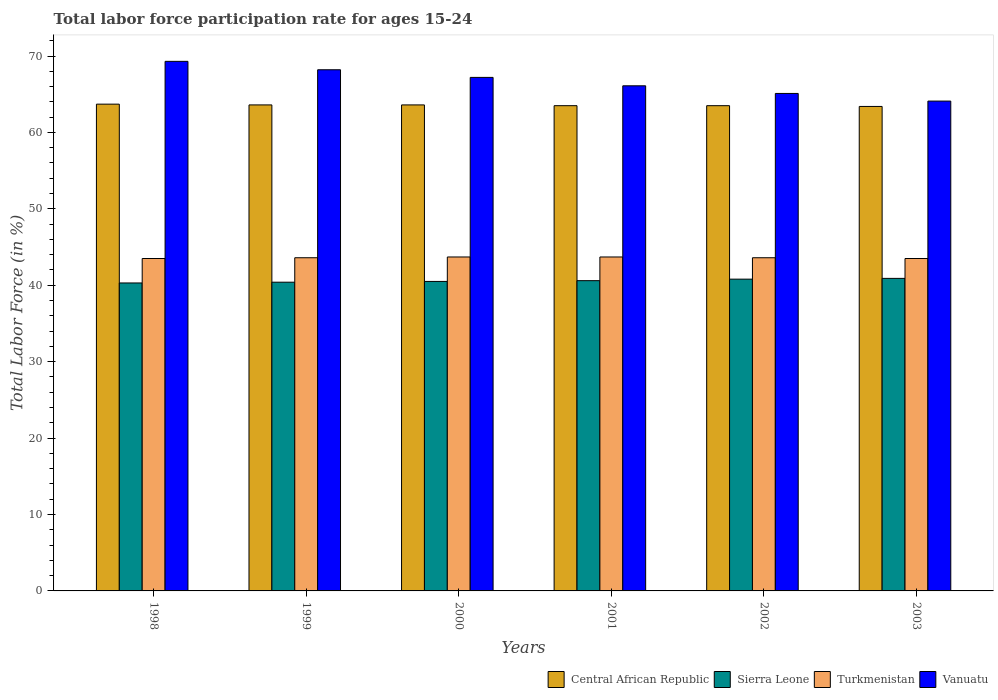How many different coloured bars are there?
Your response must be concise. 4. Are the number of bars per tick equal to the number of legend labels?
Your response must be concise. Yes. Are the number of bars on each tick of the X-axis equal?
Your response must be concise. Yes. How many bars are there on the 6th tick from the left?
Give a very brief answer. 4. What is the labor force participation rate in Turkmenistan in 1999?
Give a very brief answer. 43.6. Across all years, what is the maximum labor force participation rate in Vanuatu?
Offer a terse response. 69.3. Across all years, what is the minimum labor force participation rate in Vanuatu?
Keep it short and to the point. 64.1. In which year was the labor force participation rate in Central African Republic maximum?
Your response must be concise. 1998. In which year was the labor force participation rate in Sierra Leone minimum?
Offer a terse response. 1998. What is the total labor force participation rate in Turkmenistan in the graph?
Your answer should be compact. 261.6. What is the difference between the labor force participation rate in Central African Republic in 2000 and that in 2003?
Your answer should be very brief. 0.2. What is the difference between the labor force participation rate in Vanuatu in 1998 and the labor force participation rate in Turkmenistan in 2002?
Provide a succinct answer. 25.7. What is the average labor force participation rate in Turkmenistan per year?
Your response must be concise. 43.6. In the year 2002, what is the difference between the labor force participation rate in Vanuatu and labor force participation rate in Central African Republic?
Provide a succinct answer. 1.6. What is the ratio of the labor force participation rate in Vanuatu in 2002 to that in 2003?
Offer a very short reply. 1.02. What is the difference between the highest and the second highest labor force participation rate in Central African Republic?
Ensure brevity in your answer.  0.1. What is the difference between the highest and the lowest labor force participation rate in Sierra Leone?
Ensure brevity in your answer.  0.6. In how many years, is the labor force participation rate in Central African Republic greater than the average labor force participation rate in Central African Republic taken over all years?
Give a very brief answer. 3. Is it the case that in every year, the sum of the labor force participation rate in Central African Republic and labor force participation rate in Turkmenistan is greater than the sum of labor force participation rate in Vanuatu and labor force participation rate in Sierra Leone?
Ensure brevity in your answer.  No. What does the 1st bar from the left in 2000 represents?
Offer a terse response. Central African Republic. What does the 1st bar from the right in 2001 represents?
Ensure brevity in your answer.  Vanuatu. How many bars are there?
Offer a very short reply. 24. Are all the bars in the graph horizontal?
Your answer should be compact. No. How many years are there in the graph?
Provide a short and direct response. 6. Are the values on the major ticks of Y-axis written in scientific E-notation?
Provide a short and direct response. No. How many legend labels are there?
Keep it short and to the point. 4. How are the legend labels stacked?
Provide a succinct answer. Horizontal. What is the title of the graph?
Keep it short and to the point. Total labor force participation rate for ages 15-24. What is the Total Labor Force (in %) of Central African Republic in 1998?
Offer a very short reply. 63.7. What is the Total Labor Force (in %) in Sierra Leone in 1998?
Keep it short and to the point. 40.3. What is the Total Labor Force (in %) in Turkmenistan in 1998?
Your answer should be compact. 43.5. What is the Total Labor Force (in %) in Vanuatu in 1998?
Offer a terse response. 69.3. What is the Total Labor Force (in %) in Central African Republic in 1999?
Your response must be concise. 63.6. What is the Total Labor Force (in %) in Sierra Leone in 1999?
Give a very brief answer. 40.4. What is the Total Labor Force (in %) of Turkmenistan in 1999?
Your answer should be compact. 43.6. What is the Total Labor Force (in %) in Vanuatu in 1999?
Offer a very short reply. 68.2. What is the Total Labor Force (in %) in Central African Republic in 2000?
Provide a short and direct response. 63.6. What is the Total Labor Force (in %) in Sierra Leone in 2000?
Offer a very short reply. 40.5. What is the Total Labor Force (in %) in Turkmenistan in 2000?
Your response must be concise. 43.7. What is the Total Labor Force (in %) of Vanuatu in 2000?
Make the answer very short. 67.2. What is the Total Labor Force (in %) of Central African Republic in 2001?
Make the answer very short. 63.5. What is the Total Labor Force (in %) in Sierra Leone in 2001?
Give a very brief answer. 40.6. What is the Total Labor Force (in %) of Turkmenistan in 2001?
Keep it short and to the point. 43.7. What is the Total Labor Force (in %) of Vanuatu in 2001?
Provide a short and direct response. 66.1. What is the Total Labor Force (in %) in Central African Republic in 2002?
Your response must be concise. 63.5. What is the Total Labor Force (in %) in Sierra Leone in 2002?
Keep it short and to the point. 40.8. What is the Total Labor Force (in %) of Turkmenistan in 2002?
Offer a terse response. 43.6. What is the Total Labor Force (in %) in Vanuatu in 2002?
Ensure brevity in your answer.  65.1. What is the Total Labor Force (in %) in Central African Republic in 2003?
Offer a very short reply. 63.4. What is the Total Labor Force (in %) of Sierra Leone in 2003?
Offer a terse response. 40.9. What is the Total Labor Force (in %) in Turkmenistan in 2003?
Provide a succinct answer. 43.5. What is the Total Labor Force (in %) of Vanuatu in 2003?
Your response must be concise. 64.1. Across all years, what is the maximum Total Labor Force (in %) of Central African Republic?
Your response must be concise. 63.7. Across all years, what is the maximum Total Labor Force (in %) in Sierra Leone?
Ensure brevity in your answer.  40.9. Across all years, what is the maximum Total Labor Force (in %) of Turkmenistan?
Your answer should be very brief. 43.7. Across all years, what is the maximum Total Labor Force (in %) in Vanuatu?
Offer a terse response. 69.3. Across all years, what is the minimum Total Labor Force (in %) of Central African Republic?
Offer a terse response. 63.4. Across all years, what is the minimum Total Labor Force (in %) of Sierra Leone?
Provide a succinct answer. 40.3. Across all years, what is the minimum Total Labor Force (in %) of Turkmenistan?
Make the answer very short. 43.5. Across all years, what is the minimum Total Labor Force (in %) of Vanuatu?
Provide a short and direct response. 64.1. What is the total Total Labor Force (in %) of Central African Republic in the graph?
Ensure brevity in your answer.  381.3. What is the total Total Labor Force (in %) of Sierra Leone in the graph?
Offer a very short reply. 243.5. What is the total Total Labor Force (in %) of Turkmenistan in the graph?
Give a very brief answer. 261.6. What is the difference between the Total Labor Force (in %) of Sierra Leone in 1998 and that in 1999?
Keep it short and to the point. -0.1. What is the difference between the Total Labor Force (in %) in Turkmenistan in 1998 and that in 2000?
Your answer should be compact. -0.2. What is the difference between the Total Labor Force (in %) of Central African Republic in 1998 and that in 2001?
Your answer should be compact. 0.2. What is the difference between the Total Labor Force (in %) in Vanuatu in 1998 and that in 2001?
Make the answer very short. 3.2. What is the difference between the Total Labor Force (in %) of Central African Republic in 1998 and that in 2002?
Your answer should be compact. 0.2. What is the difference between the Total Labor Force (in %) of Turkmenistan in 1998 and that in 2002?
Offer a very short reply. -0.1. What is the difference between the Total Labor Force (in %) of Sierra Leone in 1999 and that in 2000?
Offer a very short reply. -0.1. What is the difference between the Total Labor Force (in %) in Turkmenistan in 1999 and that in 2000?
Make the answer very short. -0.1. What is the difference between the Total Labor Force (in %) of Vanuatu in 1999 and that in 2000?
Provide a short and direct response. 1. What is the difference between the Total Labor Force (in %) in Central African Republic in 1999 and that in 2001?
Provide a short and direct response. 0.1. What is the difference between the Total Labor Force (in %) in Turkmenistan in 1999 and that in 2001?
Offer a terse response. -0.1. What is the difference between the Total Labor Force (in %) of Sierra Leone in 1999 and that in 2002?
Offer a very short reply. -0.4. What is the difference between the Total Labor Force (in %) in Central African Republic in 1999 and that in 2003?
Offer a terse response. 0.2. What is the difference between the Total Labor Force (in %) in Sierra Leone in 1999 and that in 2003?
Provide a short and direct response. -0.5. What is the difference between the Total Labor Force (in %) of Turkmenistan in 1999 and that in 2003?
Offer a terse response. 0.1. What is the difference between the Total Labor Force (in %) in Vanuatu in 1999 and that in 2003?
Your answer should be very brief. 4.1. What is the difference between the Total Labor Force (in %) of Central African Republic in 2000 and that in 2001?
Ensure brevity in your answer.  0.1. What is the difference between the Total Labor Force (in %) in Sierra Leone in 2000 and that in 2001?
Offer a terse response. -0.1. What is the difference between the Total Labor Force (in %) of Central African Republic in 2000 and that in 2002?
Make the answer very short. 0.1. What is the difference between the Total Labor Force (in %) of Sierra Leone in 2000 and that in 2002?
Provide a short and direct response. -0.3. What is the difference between the Total Labor Force (in %) in Turkmenistan in 2000 and that in 2002?
Provide a short and direct response. 0.1. What is the difference between the Total Labor Force (in %) of Vanuatu in 2000 and that in 2002?
Offer a terse response. 2.1. What is the difference between the Total Labor Force (in %) of Central African Republic in 2000 and that in 2003?
Give a very brief answer. 0.2. What is the difference between the Total Labor Force (in %) of Sierra Leone in 2000 and that in 2003?
Your answer should be compact. -0.4. What is the difference between the Total Labor Force (in %) of Turkmenistan in 2000 and that in 2003?
Ensure brevity in your answer.  0.2. What is the difference between the Total Labor Force (in %) in Central African Republic in 2001 and that in 2002?
Your response must be concise. 0. What is the difference between the Total Labor Force (in %) in Vanuatu in 2001 and that in 2002?
Provide a succinct answer. 1. What is the difference between the Total Labor Force (in %) of Sierra Leone in 2001 and that in 2003?
Keep it short and to the point. -0.3. What is the difference between the Total Labor Force (in %) of Vanuatu in 2001 and that in 2003?
Provide a succinct answer. 2. What is the difference between the Total Labor Force (in %) of Central African Republic in 2002 and that in 2003?
Your answer should be compact. 0.1. What is the difference between the Total Labor Force (in %) in Vanuatu in 2002 and that in 2003?
Ensure brevity in your answer.  1. What is the difference between the Total Labor Force (in %) in Central African Republic in 1998 and the Total Labor Force (in %) in Sierra Leone in 1999?
Offer a very short reply. 23.3. What is the difference between the Total Labor Force (in %) in Central African Republic in 1998 and the Total Labor Force (in %) in Turkmenistan in 1999?
Make the answer very short. 20.1. What is the difference between the Total Labor Force (in %) in Sierra Leone in 1998 and the Total Labor Force (in %) in Vanuatu in 1999?
Your answer should be very brief. -27.9. What is the difference between the Total Labor Force (in %) in Turkmenistan in 1998 and the Total Labor Force (in %) in Vanuatu in 1999?
Provide a short and direct response. -24.7. What is the difference between the Total Labor Force (in %) in Central African Republic in 1998 and the Total Labor Force (in %) in Sierra Leone in 2000?
Offer a very short reply. 23.2. What is the difference between the Total Labor Force (in %) of Sierra Leone in 1998 and the Total Labor Force (in %) of Turkmenistan in 2000?
Provide a succinct answer. -3.4. What is the difference between the Total Labor Force (in %) of Sierra Leone in 1998 and the Total Labor Force (in %) of Vanuatu in 2000?
Offer a very short reply. -26.9. What is the difference between the Total Labor Force (in %) of Turkmenistan in 1998 and the Total Labor Force (in %) of Vanuatu in 2000?
Make the answer very short. -23.7. What is the difference between the Total Labor Force (in %) of Central African Republic in 1998 and the Total Labor Force (in %) of Sierra Leone in 2001?
Ensure brevity in your answer.  23.1. What is the difference between the Total Labor Force (in %) in Central African Republic in 1998 and the Total Labor Force (in %) in Turkmenistan in 2001?
Keep it short and to the point. 20. What is the difference between the Total Labor Force (in %) of Sierra Leone in 1998 and the Total Labor Force (in %) of Vanuatu in 2001?
Your answer should be compact. -25.8. What is the difference between the Total Labor Force (in %) in Turkmenistan in 1998 and the Total Labor Force (in %) in Vanuatu in 2001?
Provide a short and direct response. -22.6. What is the difference between the Total Labor Force (in %) in Central African Republic in 1998 and the Total Labor Force (in %) in Sierra Leone in 2002?
Provide a short and direct response. 22.9. What is the difference between the Total Labor Force (in %) of Central African Republic in 1998 and the Total Labor Force (in %) of Turkmenistan in 2002?
Ensure brevity in your answer.  20.1. What is the difference between the Total Labor Force (in %) of Sierra Leone in 1998 and the Total Labor Force (in %) of Vanuatu in 2002?
Provide a succinct answer. -24.8. What is the difference between the Total Labor Force (in %) in Turkmenistan in 1998 and the Total Labor Force (in %) in Vanuatu in 2002?
Provide a succinct answer. -21.6. What is the difference between the Total Labor Force (in %) in Central African Republic in 1998 and the Total Labor Force (in %) in Sierra Leone in 2003?
Make the answer very short. 22.8. What is the difference between the Total Labor Force (in %) of Central African Republic in 1998 and the Total Labor Force (in %) of Turkmenistan in 2003?
Offer a terse response. 20.2. What is the difference between the Total Labor Force (in %) of Central African Republic in 1998 and the Total Labor Force (in %) of Vanuatu in 2003?
Ensure brevity in your answer.  -0.4. What is the difference between the Total Labor Force (in %) in Sierra Leone in 1998 and the Total Labor Force (in %) in Vanuatu in 2003?
Make the answer very short. -23.8. What is the difference between the Total Labor Force (in %) of Turkmenistan in 1998 and the Total Labor Force (in %) of Vanuatu in 2003?
Your response must be concise. -20.6. What is the difference between the Total Labor Force (in %) of Central African Republic in 1999 and the Total Labor Force (in %) of Sierra Leone in 2000?
Provide a short and direct response. 23.1. What is the difference between the Total Labor Force (in %) in Sierra Leone in 1999 and the Total Labor Force (in %) in Turkmenistan in 2000?
Make the answer very short. -3.3. What is the difference between the Total Labor Force (in %) in Sierra Leone in 1999 and the Total Labor Force (in %) in Vanuatu in 2000?
Provide a short and direct response. -26.8. What is the difference between the Total Labor Force (in %) in Turkmenistan in 1999 and the Total Labor Force (in %) in Vanuatu in 2000?
Your response must be concise. -23.6. What is the difference between the Total Labor Force (in %) of Central African Republic in 1999 and the Total Labor Force (in %) of Sierra Leone in 2001?
Offer a very short reply. 23. What is the difference between the Total Labor Force (in %) in Central African Republic in 1999 and the Total Labor Force (in %) in Vanuatu in 2001?
Offer a terse response. -2.5. What is the difference between the Total Labor Force (in %) in Sierra Leone in 1999 and the Total Labor Force (in %) in Vanuatu in 2001?
Offer a terse response. -25.7. What is the difference between the Total Labor Force (in %) in Turkmenistan in 1999 and the Total Labor Force (in %) in Vanuatu in 2001?
Provide a short and direct response. -22.5. What is the difference between the Total Labor Force (in %) in Central African Republic in 1999 and the Total Labor Force (in %) in Sierra Leone in 2002?
Ensure brevity in your answer.  22.8. What is the difference between the Total Labor Force (in %) of Sierra Leone in 1999 and the Total Labor Force (in %) of Vanuatu in 2002?
Give a very brief answer. -24.7. What is the difference between the Total Labor Force (in %) of Turkmenistan in 1999 and the Total Labor Force (in %) of Vanuatu in 2002?
Make the answer very short. -21.5. What is the difference between the Total Labor Force (in %) of Central African Republic in 1999 and the Total Labor Force (in %) of Sierra Leone in 2003?
Give a very brief answer. 22.7. What is the difference between the Total Labor Force (in %) of Central African Republic in 1999 and the Total Labor Force (in %) of Turkmenistan in 2003?
Make the answer very short. 20.1. What is the difference between the Total Labor Force (in %) of Central African Republic in 1999 and the Total Labor Force (in %) of Vanuatu in 2003?
Give a very brief answer. -0.5. What is the difference between the Total Labor Force (in %) of Sierra Leone in 1999 and the Total Labor Force (in %) of Vanuatu in 2003?
Your answer should be very brief. -23.7. What is the difference between the Total Labor Force (in %) of Turkmenistan in 1999 and the Total Labor Force (in %) of Vanuatu in 2003?
Offer a terse response. -20.5. What is the difference between the Total Labor Force (in %) in Sierra Leone in 2000 and the Total Labor Force (in %) in Vanuatu in 2001?
Offer a terse response. -25.6. What is the difference between the Total Labor Force (in %) of Turkmenistan in 2000 and the Total Labor Force (in %) of Vanuatu in 2001?
Your answer should be compact. -22.4. What is the difference between the Total Labor Force (in %) in Central African Republic in 2000 and the Total Labor Force (in %) in Sierra Leone in 2002?
Provide a short and direct response. 22.8. What is the difference between the Total Labor Force (in %) of Central African Republic in 2000 and the Total Labor Force (in %) of Turkmenistan in 2002?
Your response must be concise. 20. What is the difference between the Total Labor Force (in %) of Central African Republic in 2000 and the Total Labor Force (in %) of Vanuatu in 2002?
Your answer should be compact. -1.5. What is the difference between the Total Labor Force (in %) in Sierra Leone in 2000 and the Total Labor Force (in %) in Turkmenistan in 2002?
Keep it short and to the point. -3.1. What is the difference between the Total Labor Force (in %) in Sierra Leone in 2000 and the Total Labor Force (in %) in Vanuatu in 2002?
Keep it short and to the point. -24.6. What is the difference between the Total Labor Force (in %) in Turkmenistan in 2000 and the Total Labor Force (in %) in Vanuatu in 2002?
Offer a terse response. -21.4. What is the difference between the Total Labor Force (in %) of Central African Republic in 2000 and the Total Labor Force (in %) of Sierra Leone in 2003?
Give a very brief answer. 22.7. What is the difference between the Total Labor Force (in %) of Central African Republic in 2000 and the Total Labor Force (in %) of Turkmenistan in 2003?
Your answer should be compact. 20.1. What is the difference between the Total Labor Force (in %) in Sierra Leone in 2000 and the Total Labor Force (in %) in Vanuatu in 2003?
Provide a succinct answer. -23.6. What is the difference between the Total Labor Force (in %) of Turkmenistan in 2000 and the Total Labor Force (in %) of Vanuatu in 2003?
Provide a short and direct response. -20.4. What is the difference between the Total Labor Force (in %) in Central African Republic in 2001 and the Total Labor Force (in %) in Sierra Leone in 2002?
Offer a terse response. 22.7. What is the difference between the Total Labor Force (in %) in Central African Republic in 2001 and the Total Labor Force (in %) in Turkmenistan in 2002?
Offer a very short reply. 19.9. What is the difference between the Total Labor Force (in %) of Sierra Leone in 2001 and the Total Labor Force (in %) of Vanuatu in 2002?
Offer a very short reply. -24.5. What is the difference between the Total Labor Force (in %) in Turkmenistan in 2001 and the Total Labor Force (in %) in Vanuatu in 2002?
Provide a succinct answer. -21.4. What is the difference between the Total Labor Force (in %) in Central African Republic in 2001 and the Total Labor Force (in %) in Sierra Leone in 2003?
Make the answer very short. 22.6. What is the difference between the Total Labor Force (in %) of Central African Republic in 2001 and the Total Labor Force (in %) of Vanuatu in 2003?
Keep it short and to the point. -0.6. What is the difference between the Total Labor Force (in %) of Sierra Leone in 2001 and the Total Labor Force (in %) of Turkmenistan in 2003?
Keep it short and to the point. -2.9. What is the difference between the Total Labor Force (in %) of Sierra Leone in 2001 and the Total Labor Force (in %) of Vanuatu in 2003?
Offer a terse response. -23.5. What is the difference between the Total Labor Force (in %) of Turkmenistan in 2001 and the Total Labor Force (in %) of Vanuatu in 2003?
Keep it short and to the point. -20.4. What is the difference between the Total Labor Force (in %) in Central African Republic in 2002 and the Total Labor Force (in %) in Sierra Leone in 2003?
Provide a short and direct response. 22.6. What is the difference between the Total Labor Force (in %) in Central African Republic in 2002 and the Total Labor Force (in %) in Turkmenistan in 2003?
Give a very brief answer. 20. What is the difference between the Total Labor Force (in %) in Central African Republic in 2002 and the Total Labor Force (in %) in Vanuatu in 2003?
Offer a very short reply. -0.6. What is the difference between the Total Labor Force (in %) of Sierra Leone in 2002 and the Total Labor Force (in %) of Turkmenistan in 2003?
Provide a short and direct response. -2.7. What is the difference between the Total Labor Force (in %) of Sierra Leone in 2002 and the Total Labor Force (in %) of Vanuatu in 2003?
Your answer should be compact. -23.3. What is the difference between the Total Labor Force (in %) in Turkmenistan in 2002 and the Total Labor Force (in %) in Vanuatu in 2003?
Offer a terse response. -20.5. What is the average Total Labor Force (in %) in Central African Republic per year?
Provide a succinct answer. 63.55. What is the average Total Labor Force (in %) in Sierra Leone per year?
Offer a terse response. 40.58. What is the average Total Labor Force (in %) of Turkmenistan per year?
Ensure brevity in your answer.  43.6. What is the average Total Labor Force (in %) of Vanuatu per year?
Ensure brevity in your answer.  66.67. In the year 1998, what is the difference between the Total Labor Force (in %) of Central African Republic and Total Labor Force (in %) of Sierra Leone?
Your answer should be compact. 23.4. In the year 1998, what is the difference between the Total Labor Force (in %) in Central African Republic and Total Labor Force (in %) in Turkmenistan?
Offer a very short reply. 20.2. In the year 1998, what is the difference between the Total Labor Force (in %) in Central African Republic and Total Labor Force (in %) in Vanuatu?
Provide a short and direct response. -5.6. In the year 1998, what is the difference between the Total Labor Force (in %) in Sierra Leone and Total Labor Force (in %) in Turkmenistan?
Your answer should be compact. -3.2. In the year 1998, what is the difference between the Total Labor Force (in %) of Sierra Leone and Total Labor Force (in %) of Vanuatu?
Provide a succinct answer. -29. In the year 1998, what is the difference between the Total Labor Force (in %) of Turkmenistan and Total Labor Force (in %) of Vanuatu?
Your response must be concise. -25.8. In the year 1999, what is the difference between the Total Labor Force (in %) of Central African Republic and Total Labor Force (in %) of Sierra Leone?
Make the answer very short. 23.2. In the year 1999, what is the difference between the Total Labor Force (in %) of Central African Republic and Total Labor Force (in %) of Vanuatu?
Offer a terse response. -4.6. In the year 1999, what is the difference between the Total Labor Force (in %) of Sierra Leone and Total Labor Force (in %) of Vanuatu?
Your answer should be compact. -27.8. In the year 1999, what is the difference between the Total Labor Force (in %) in Turkmenistan and Total Labor Force (in %) in Vanuatu?
Keep it short and to the point. -24.6. In the year 2000, what is the difference between the Total Labor Force (in %) in Central African Republic and Total Labor Force (in %) in Sierra Leone?
Provide a succinct answer. 23.1. In the year 2000, what is the difference between the Total Labor Force (in %) in Central African Republic and Total Labor Force (in %) in Turkmenistan?
Keep it short and to the point. 19.9. In the year 2000, what is the difference between the Total Labor Force (in %) in Sierra Leone and Total Labor Force (in %) in Vanuatu?
Your answer should be very brief. -26.7. In the year 2000, what is the difference between the Total Labor Force (in %) of Turkmenistan and Total Labor Force (in %) of Vanuatu?
Ensure brevity in your answer.  -23.5. In the year 2001, what is the difference between the Total Labor Force (in %) in Central African Republic and Total Labor Force (in %) in Sierra Leone?
Your response must be concise. 22.9. In the year 2001, what is the difference between the Total Labor Force (in %) in Central African Republic and Total Labor Force (in %) in Turkmenistan?
Keep it short and to the point. 19.8. In the year 2001, what is the difference between the Total Labor Force (in %) in Central African Republic and Total Labor Force (in %) in Vanuatu?
Offer a very short reply. -2.6. In the year 2001, what is the difference between the Total Labor Force (in %) of Sierra Leone and Total Labor Force (in %) of Turkmenistan?
Your response must be concise. -3.1. In the year 2001, what is the difference between the Total Labor Force (in %) in Sierra Leone and Total Labor Force (in %) in Vanuatu?
Offer a very short reply. -25.5. In the year 2001, what is the difference between the Total Labor Force (in %) of Turkmenistan and Total Labor Force (in %) of Vanuatu?
Ensure brevity in your answer.  -22.4. In the year 2002, what is the difference between the Total Labor Force (in %) in Central African Republic and Total Labor Force (in %) in Sierra Leone?
Offer a very short reply. 22.7. In the year 2002, what is the difference between the Total Labor Force (in %) of Sierra Leone and Total Labor Force (in %) of Turkmenistan?
Make the answer very short. -2.8. In the year 2002, what is the difference between the Total Labor Force (in %) in Sierra Leone and Total Labor Force (in %) in Vanuatu?
Provide a succinct answer. -24.3. In the year 2002, what is the difference between the Total Labor Force (in %) of Turkmenistan and Total Labor Force (in %) of Vanuatu?
Offer a very short reply. -21.5. In the year 2003, what is the difference between the Total Labor Force (in %) of Central African Republic and Total Labor Force (in %) of Turkmenistan?
Offer a terse response. 19.9. In the year 2003, what is the difference between the Total Labor Force (in %) in Central African Republic and Total Labor Force (in %) in Vanuatu?
Provide a short and direct response. -0.7. In the year 2003, what is the difference between the Total Labor Force (in %) in Sierra Leone and Total Labor Force (in %) in Vanuatu?
Your answer should be compact. -23.2. In the year 2003, what is the difference between the Total Labor Force (in %) of Turkmenistan and Total Labor Force (in %) of Vanuatu?
Provide a succinct answer. -20.6. What is the ratio of the Total Labor Force (in %) in Central African Republic in 1998 to that in 1999?
Your answer should be very brief. 1. What is the ratio of the Total Labor Force (in %) of Turkmenistan in 1998 to that in 1999?
Offer a terse response. 1. What is the ratio of the Total Labor Force (in %) of Vanuatu in 1998 to that in 1999?
Offer a terse response. 1.02. What is the ratio of the Total Labor Force (in %) of Turkmenistan in 1998 to that in 2000?
Give a very brief answer. 1. What is the ratio of the Total Labor Force (in %) in Vanuatu in 1998 to that in 2000?
Your answer should be compact. 1.03. What is the ratio of the Total Labor Force (in %) of Central African Republic in 1998 to that in 2001?
Your response must be concise. 1. What is the ratio of the Total Labor Force (in %) of Sierra Leone in 1998 to that in 2001?
Provide a short and direct response. 0.99. What is the ratio of the Total Labor Force (in %) in Vanuatu in 1998 to that in 2001?
Keep it short and to the point. 1.05. What is the ratio of the Total Labor Force (in %) in Central African Republic in 1998 to that in 2002?
Offer a very short reply. 1. What is the ratio of the Total Labor Force (in %) in Vanuatu in 1998 to that in 2002?
Provide a succinct answer. 1.06. What is the ratio of the Total Labor Force (in %) in Sierra Leone in 1998 to that in 2003?
Offer a very short reply. 0.99. What is the ratio of the Total Labor Force (in %) of Turkmenistan in 1998 to that in 2003?
Keep it short and to the point. 1. What is the ratio of the Total Labor Force (in %) in Vanuatu in 1998 to that in 2003?
Give a very brief answer. 1.08. What is the ratio of the Total Labor Force (in %) of Central African Republic in 1999 to that in 2000?
Ensure brevity in your answer.  1. What is the ratio of the Total Labor Force (in %) of Sierra Leone in 1999 to that in 2000?
Provide a succinct answer. 1. What is the ratio of the Total Labor Force (in %) of Vanuatu in 1999 to that in 2000?
Your answer should be very brief. 1.01. What is the ratio of the Total Labor Force (in %) in Turkmenistan in 1999 to that in 2001?
Keep it short and to the point. 1. What is the ratio of the Total Labor Force (in %) of Vanuatu in 1999 to that in 2001?
Your answer should be compact. 1.03. What is the ratio of the Total Labor Force (in %) of Central African Republic in 1999 to that in 2002?
Provide a succinct answer. 1. What is the ratio of the Total Labor Force (in %) in Sierra Leone in 1999 to that in 2002?
Offer a terse response. 0.99. What is the ratio of the Total Labor Force (in %) in Turkmenistan in 1999 to that in 2002?
Give a very brief answer. 1. What is the ratio of the Total Labor Force (in %) of Vanuatu in 1999 to that in 2002?
Your response must be concise. 1.05. What is the ratio of the Total Labor Force (in %) of Central African Republic in 1999 to that in 2003?
Make the answer very short. 1. What is the ratio of the Total Labor Force (in %) in Turkmenistan in 1999 to that in 2003?
Provide a short and direct response. 1. What is the ratio of the Total Labor Force (in %) in Vanuatu in 1999 to that in 2003?
Ensure brevity in your answer.  1.06. What is the ratio of the Total Labor Force (in %) of Vanuatu in 2000 to that in 2001?
Offer a terse response. 1.02. What is the ratio of the Total Labor Force (in %) of Central African Republic in 2000 to that in 2002?
Keep it short and to the point. 1. What is the ratio of the Total Labor Force (in %) of Sierra Leone in 2000 to that in 2002?
Offer a terse response. 0.99. What is the ratio of the Total Labor Force (in %) of Vanuatu in 2000 to that in 2002?
Provide a short and direct response. 1.03. What is the ratio of the Total Labor Force (in %) in Central African Republic in 2000 to that in 2003?
Keep it short and to the point. 1. What is the ratio of the Total Labor Force (in %) in Sierra Leone in 2000 to that in 2003?
Provide a short and direct response. 0.99. What is the ratio of the Total Labor Force (in %) in Vanuatu in 2000 to that in 2003?
Your response must be concise. 1.05. What is the ratio of the Total Labor Force (in %) of Central African Republic in 2001 to that in 2002?
Give a very brief answer. 1. What is the ratio of the Total Labor Force (in %) in Sierra Leone in 2001 to that in 2002?
Offer a very short reply. 1. What is the ratio of the Total Labor Force (in %) of Vanuatu in 2001 to that in 2002?
Provide a succinct answer. 1.02. What is the ratio of the Total Labor Force (in %) of Central African Republic in 2001 to that in 2003?
Offer a terse response. 1. What is the ratio of the Total Labor Force (in %) of Sierra Leone in 2001 to that in 2003?
Offer a very short reply. 0.99. What is the ratio of the Total Labor Force (in %) of Vanuatu in 2001 to that in 2003?
Offer a terse response. 1.03. What is the ratio of the Total Labor Force (in %) in Sierra Leone in 2002 to that in 2003?
Offer a terse response. 1. What is the ratio of the Total Labor Force (in %) in Turkmenistan in 2002 to that in 2003?
Keep it short and to the point. 1. What is the ratio of the Total Labor Force (in %) of Vanuatu in 2002 to that in 2003?
Ensure brevity in your answer.  1.02. What is the difference between the highest and the second highest Total Labor Force (in %) of Central African Republic?
Make the answer very short. 0.1. What is the difference between the highest and the second highest Total Labor Force (in %) of Turkmenistan?
Make the answer very short. 0. What is the difference between the highest and the second highest Total Labor Force (in %) in Vanuatu?
Provide a short and direct response. 1.1. What is the difference between the highest and the lowest Total Labor Force (in %) of Central African Republic?
Make the answer very short. 0.3. What is the difference between the highest and the lowest Total Labor Force (in %) of Sierra Leone?
Ensure brevity in your answer.  0.6. What is the difference between the highest and the lowest Total Labor Force (in %) in Turkmenistan?
Offer a very short reply. 0.2. What is the difference between the highest and the lowest Total Labor Force (in %) in Vanuatu?
Ensure brevity in your answer.  5.2. 